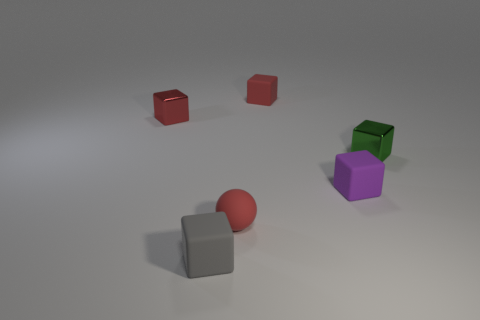Subtract all red metallic blocks. How many blocks are left? 4 Subtract all green cubes. How many cubes are left? 4 Subtract all yellow cubes. Subtract all green balls. How many cubes are left? 5 Add 1 purple metal cubes. How many objects exist? 7 Subtract all balls. How many objects are left? 5 Subtract 0 blue spheres. How many objects are left? 6 Subtract all red cubes. Subtract all green objects. How many objects are left? 3 Add 1 tiny red rubber spheres. How many tiny red rubber spheres are left? 2 Add 1 small rubber cylinders. How many small rubber cylinders exist? 1 